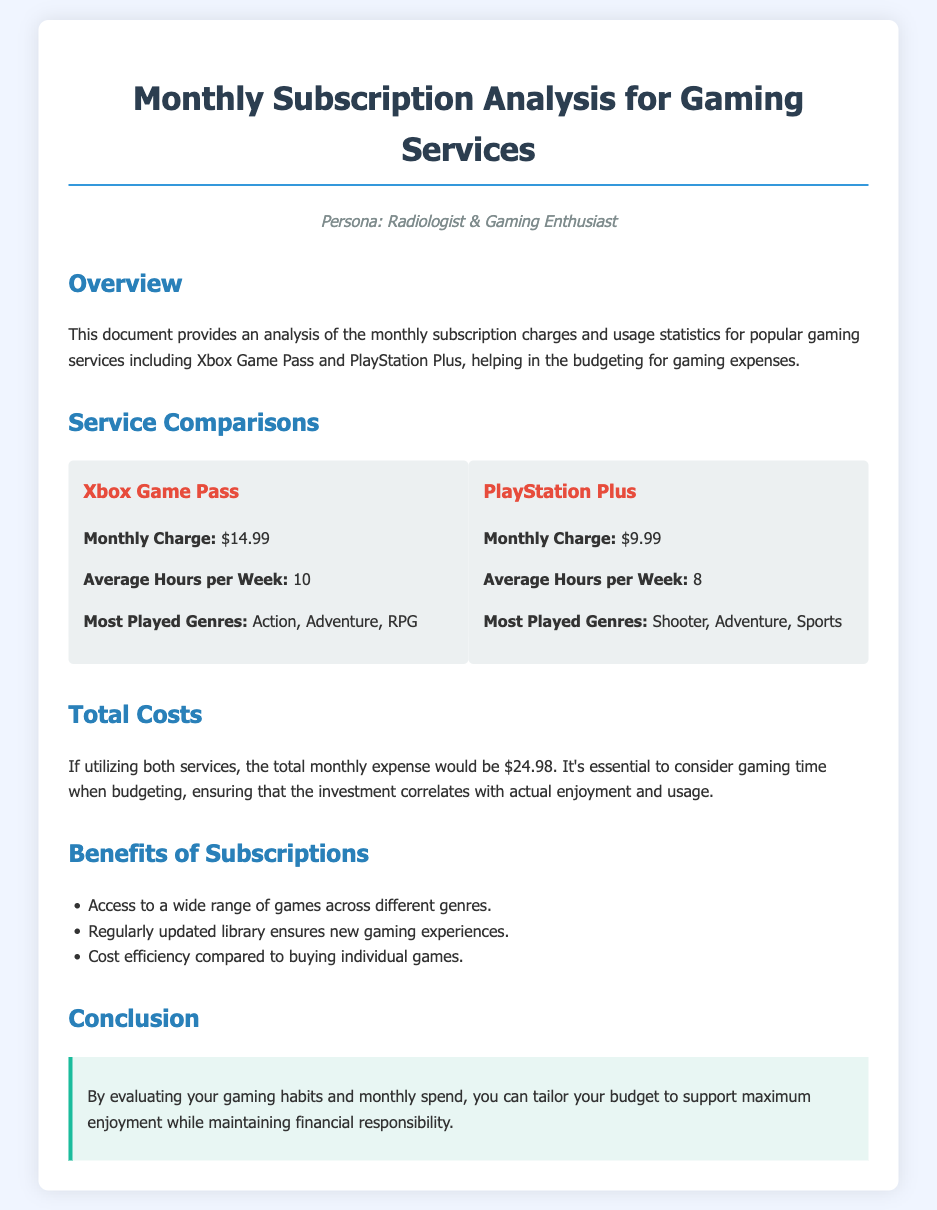what is the monthly charge for Xbox Game Pass? The monthly charge for Xbox Game Pass is specified in the document.
Answer: $14.99 what is the average usage for PlayStation Plus? The document provides the average hours per week for PlayStation Plus, which indicates usage.
Answer: 8 what are the most played genres for Xbox Game Pass? The document lists the most played genres for Xbox Game Pass as part of its comparison.
Answer: Action, Adventure, RPG what is the total monthly expense for utilizing both services? The document calculates the total expense if both services are used, showing the combined cost.
Answer: $24.98 what benefit of subscriptions is mentioned related to the game library? The document highlights benefits of subscriptions, including updates to games.
Answer: Regularly updated library ensures new gaming experiences which gaming service has a lower monthly charge? The document allows comparison of charges for the two services to find which is cheaper.
Answer: PlayStation Plus how many hours per week do users typically spend on Xbox Game Pass? The document states the average hours spent weekly on Xbox Game Pass, which is a key statistic.
Answer: 10 what is the persona described in this document? The document describes the persona to contextualize its analysis and recommendations.
Answer: Radiologist & Gaming Enthusiast 